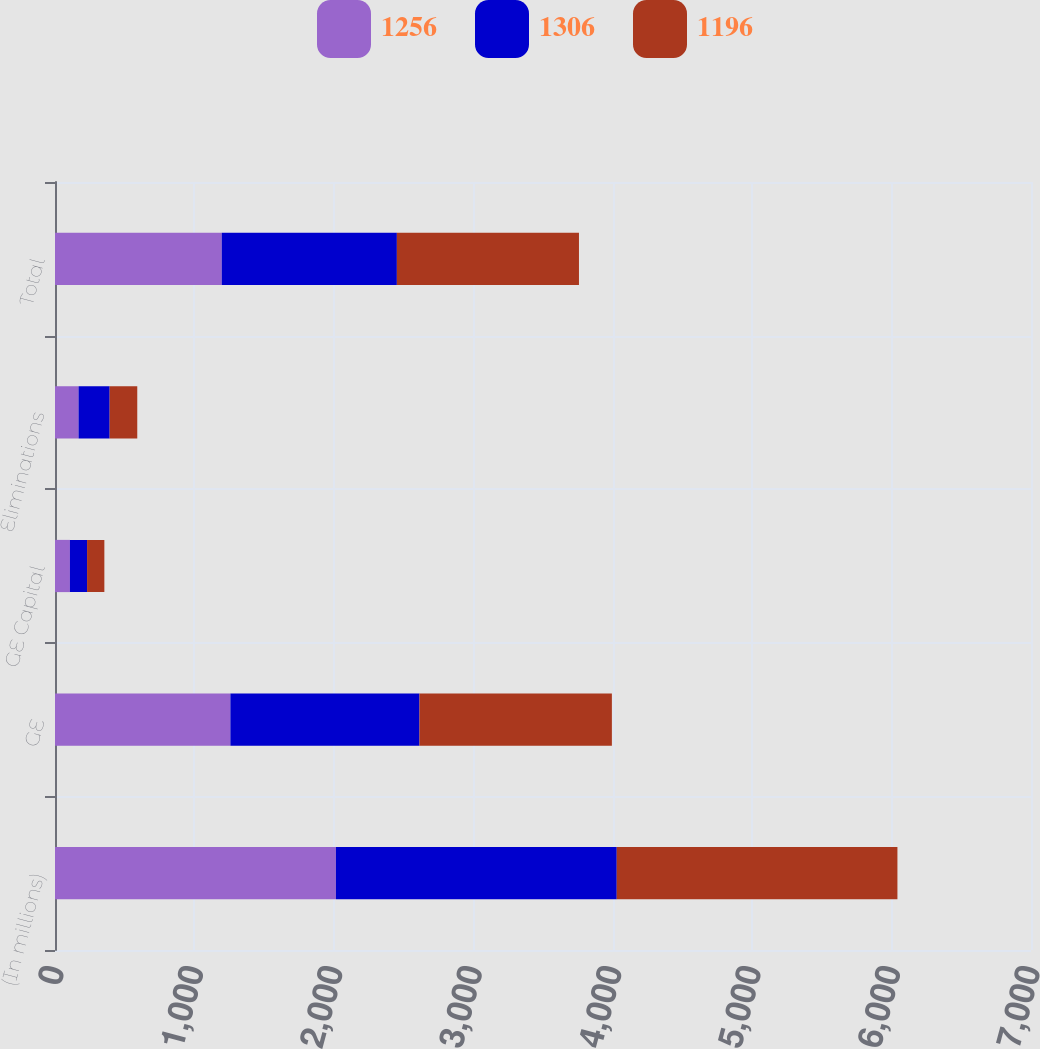Convert chart. <chart><loc_0><loc_0><loc_500><loc_500><stacked_bar_chart><ecel><fcel>(In millions)<fcel>GE<fcel>GE Capital<fcel>Eliminations<fcel>Total<nl><fcel>1256<fcel>2015<fcel>1258<fcel>107<fcel>169<fcel>1196<nl><fcel>1306<fcel>2014<fcel>1356<fcel>123<fcel>223<fcel>1256<nl><fcel>1196<fcel>2013<fcel>1380<fcel>124<fcel>198<fcel>1306<nl></chart> 